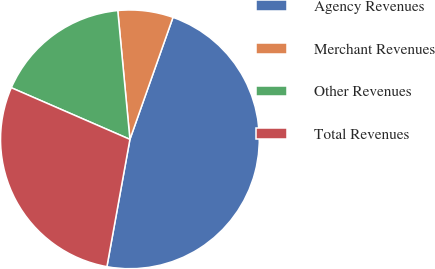Convert chart. <chart><loc_0><loc_0><loc_500><loc_500><pie_chart><fcel>Agency Revenues<fcel>Merchant Revenues<fcel>Other Revenues<fcel>Total Revenues<nl><fcel>47.45%<fcel>6.9%<fcel>16.97%<fcel>28.69%<nl></chart> 